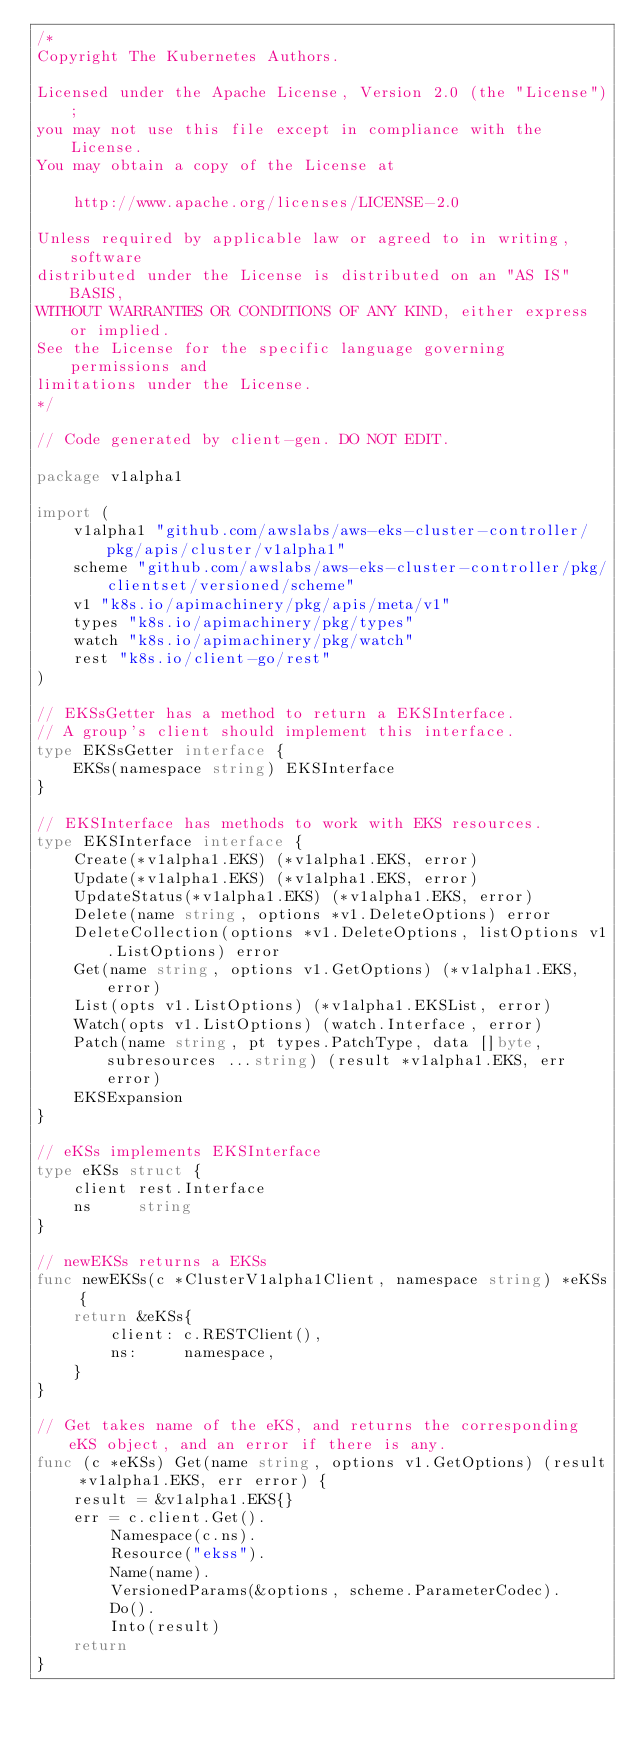Convert code to text. <code><loc_0><loc_0><loc_500><loc_500><_Go_>/*
Copyright The Kubernetes Authors.

Licensed under the Apache License, Version 2.0 (the "License");
you may not use this file except in compliance with the License.
You may obtain a copy of the License at

    http://www.apache.org/licenses/LICENSE-2.0

Unless required by applicable law or agreed to in writing, software
distributed under the License is distributed on an "AS IS" BASIS,
WITHOUT WARRANTIES OR CONDITIONS OF ANY KIND, either express or implied.
See the License for the specific language governing permissions and
limitations under the License.
*/

// Code generated by client-gen. DO NOT EDIT.

package v1alpha1

import (
	v1alpha1 "github.com/awslabs/aws-eks-cluster-controller/pkg/apis/cluster/v1alpha1"
	scheme "github.com/awslabs/aws-eks-cluster-controller/pkg/clientset/versioned/scheme"
	v1 "k8s.io/apimachinery/pkg/apis/meta/v1"
	types "k8s.io/apimachinery/pkg/types"
	watch "k8s.io/apimachinery/pkg/watch"
	rest "k8s.io/client-go/rest"
)

// EKSsGetter has a method to return a EKSInterface.
// A group's client should implement this interface.
type EKSsGetter interface {
	EKSs(namespace string) EKSInterface
}

// EKSInterface has methods to work with EKS resources.
type EKSInterface interface {
	Create(*v1alpha1.EKS) (*v1alpha1.EKS, error)
	Update(*v1alpha1.EKS) (*v1alpha1.EKS, error)
	UpdateStatus(*v1alpha1.EKS) (*v1alpha1.EKS, error)
	Delete(name string, options *v1.DeleteOptions) error
	DeleteCollection(options *v1.DeleteOptions, listOptions v1.ListOptions) error
	Get(name string, options v1.GetOptions) (*v1alpha1.EKS, error)
	List(opts v1.ListOptions) (*v1alpha1.EKSList, error)
	Watch(opts v1.ListOptions) (watch.Interface, error)
	Patch(name string, pt types.PatchType, data []byte, subresources ...string) (result *v1alpha1.EKS, err error)
	EKSExpansion
}

// eKSs implements EKSInterface
type eKSs struct {
	client rest.Interface
	ns     string
}

// newEKSs returns a EKSs
func newEKSs(c *ClusterV1alpha1Client, namespace string) *eKSs {
	return &eKSs{
		client: c.RESTClient(),
		ns:     namespace,
	}
}

// Get takes name of the eKS, and returns the corresponding eKS object, and an error if there is any.
func (c *eKSs) Get(name string, options v1.GetOptions) (result *v1alpha1.EKS, err error) {
	result = &v1alpha1.EKS{}
	err = c.client.Get().
		Namespace(c.ns).
		Resource("ekss").
		Name(name).
		VersionedParams(&options, scheme.ParameterCodec).
		Do().
		Into(result)
	return
}
</code> 